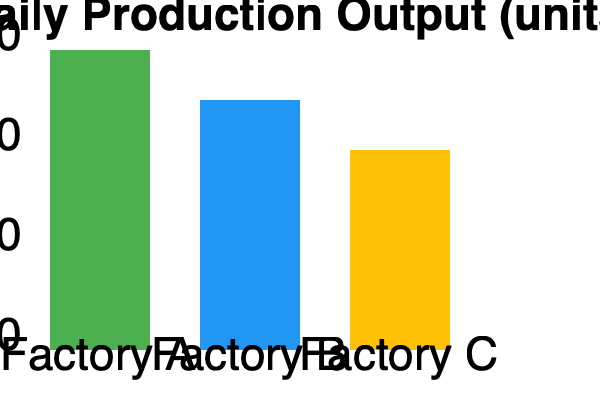Based on the bar chart showing daily production output for three factories and given that Factory A has a production flow efficiency of 85%, calculate the approximate production flow efficiency of Factory C. Assume that production flow efficiency is directly proportional to daily output. To solve this problem, we'll follow these steps:

1. Identify the daily production output for Factory A and Factory C from the bar chart:
   Factory A: 300 units
   Factory C: 200 units

2. Set up a proportion to relate production flow efficiency to daily output:
   Let x be the production flow efficiency of Factory C.
   
   $$\frac{\text{Efficiency A}}{\text{Output A}} = \frac{\text{Efficiency C}}{\text{Output C}}$$

3. Substitute the known values:
   $$\frac{85\%}{300} = \frac{x}{200}$$

4. Cross-multiply:
   $$85 \times 200 = 300x$$

5. Solve for x:
   $$x = \frac{85 \times 200}{300} = \frac{17000}{300} \approx 56.67\%$$

Therefore, the approximate production flow efficiency of Factory C is 56.67%.
Answer: 56.67% 